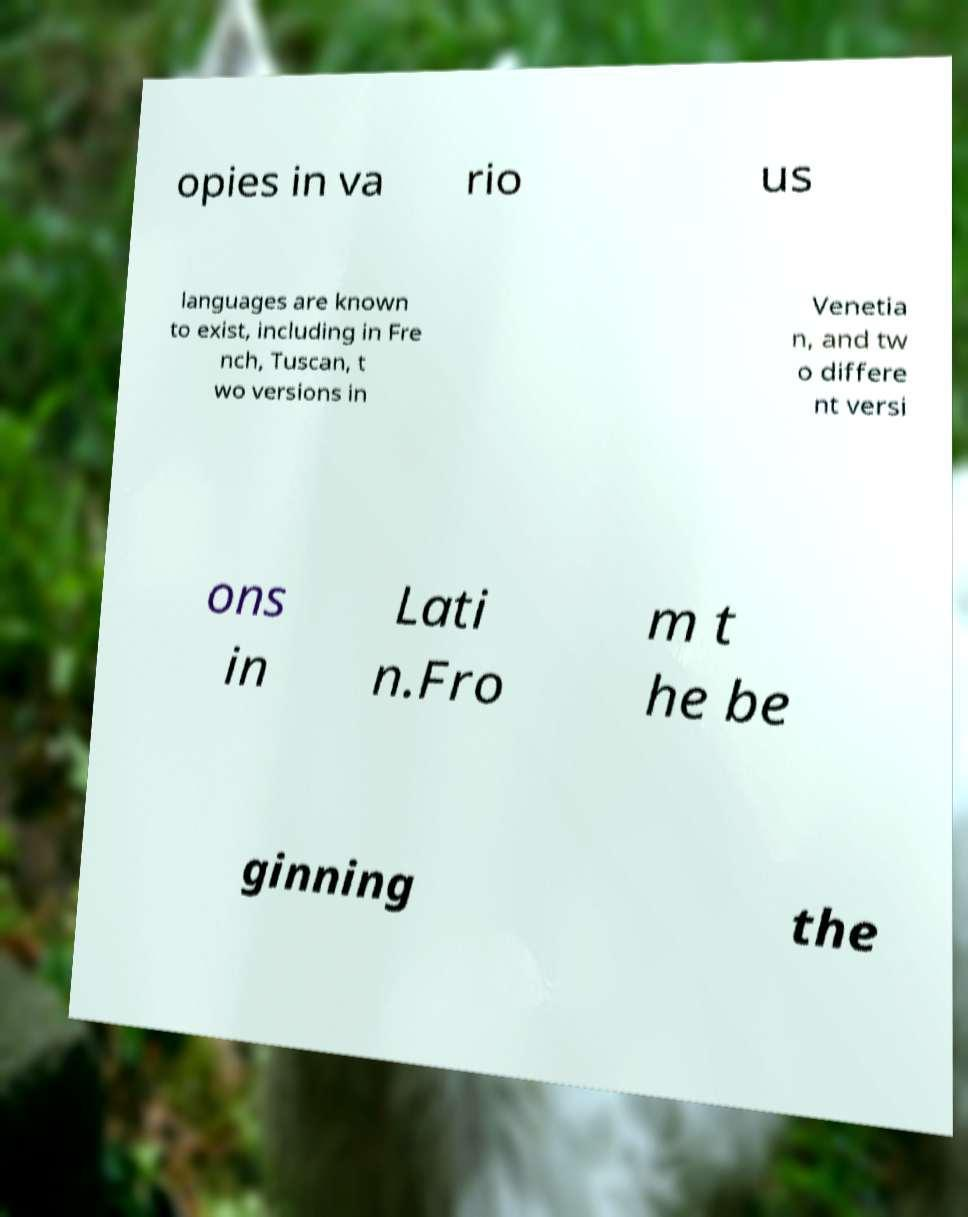Can you accurately transcribe the text from the provided image for me? opies in va rio us languages are known to exist, including in Fre nch, Tuscan, t wo versions in Venetia n, and tw o differe nt versi ons in Lati n.Fro m t he be ginning the 